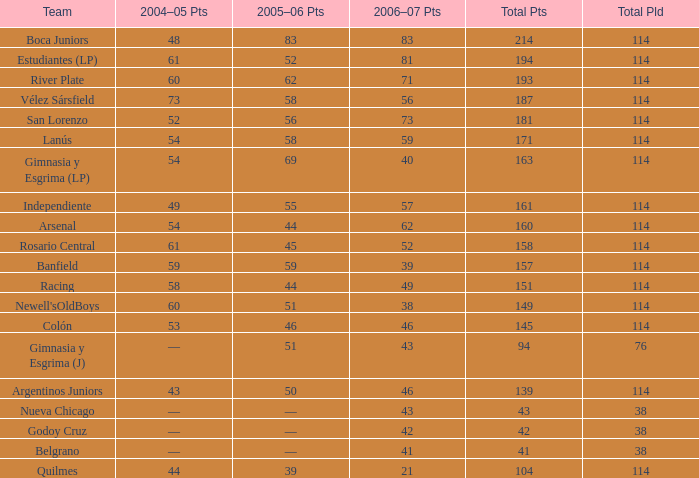What is the average total pld with 45 points in 2005-06, and more than 52 points in 2006-07? None. 